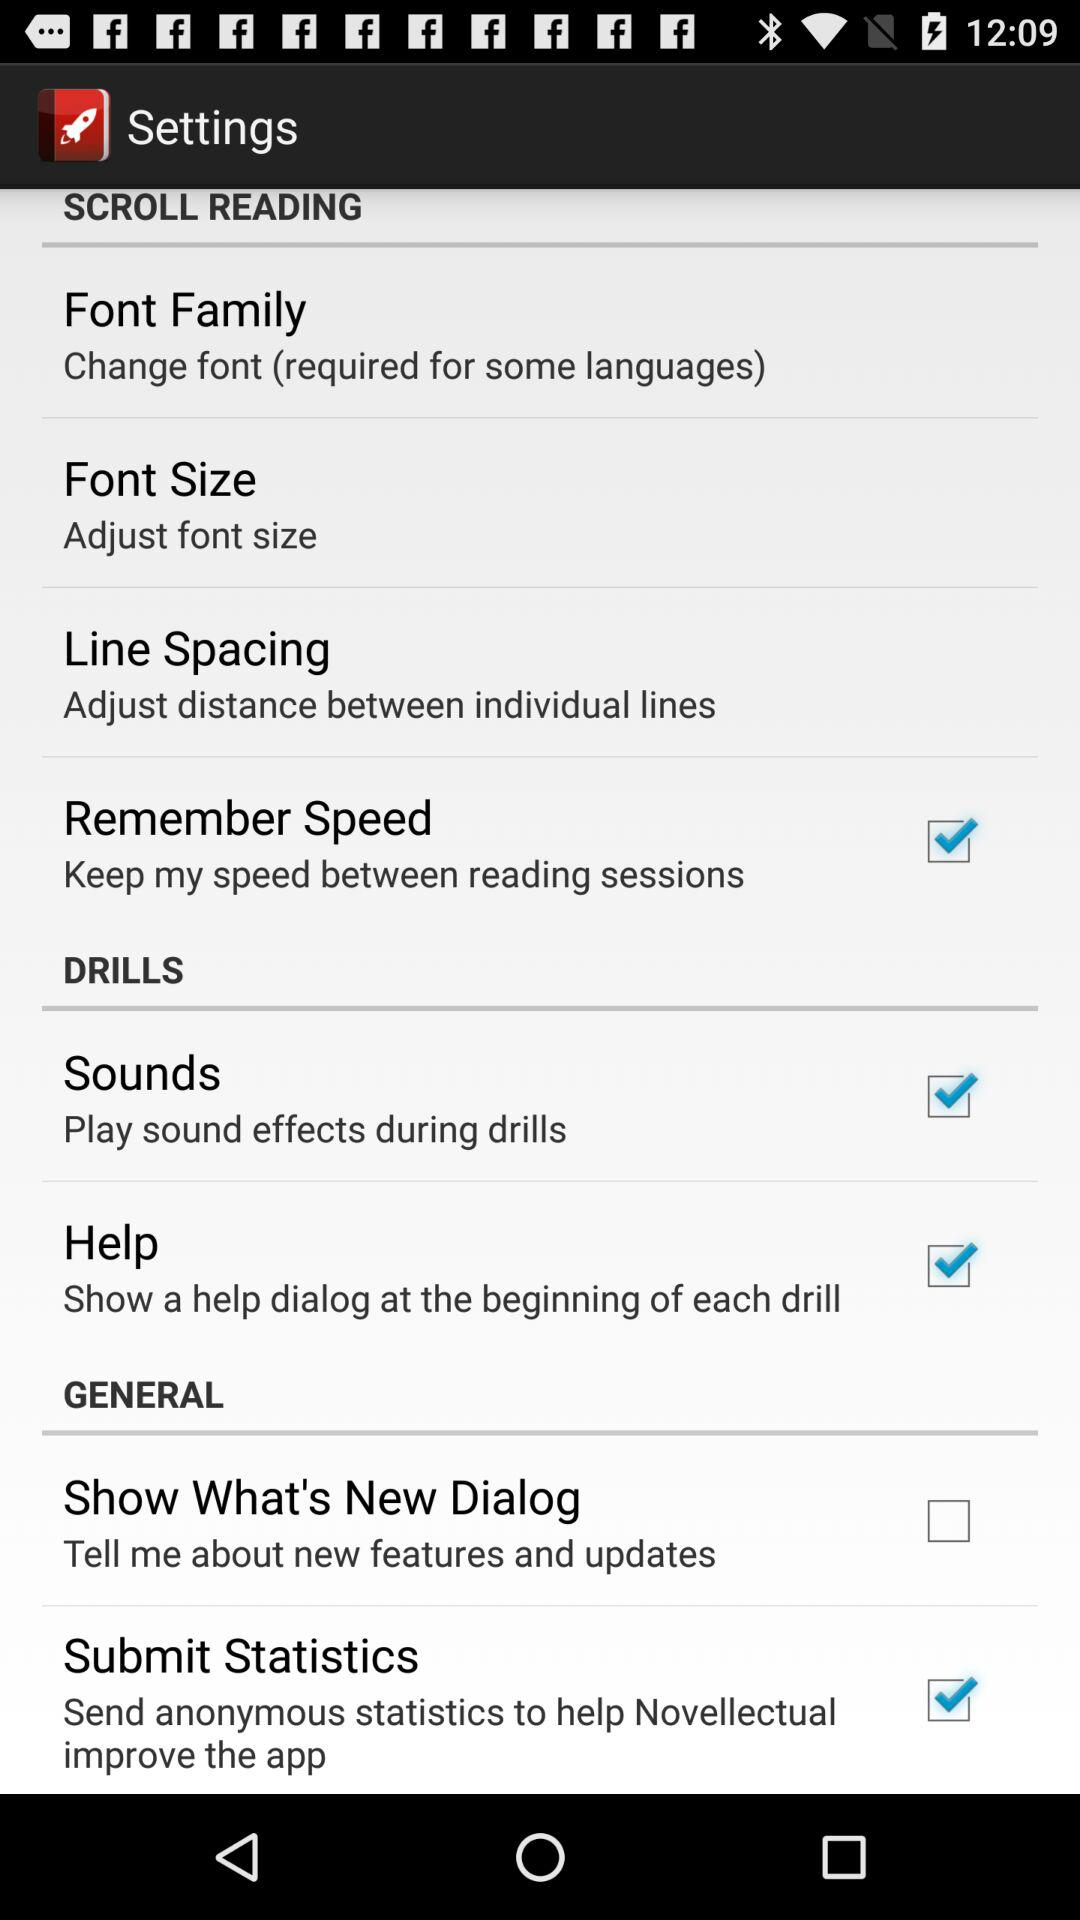Which font size is currently selected?
When the provided information is insufficient, respond with <no answer>. <no answer> 